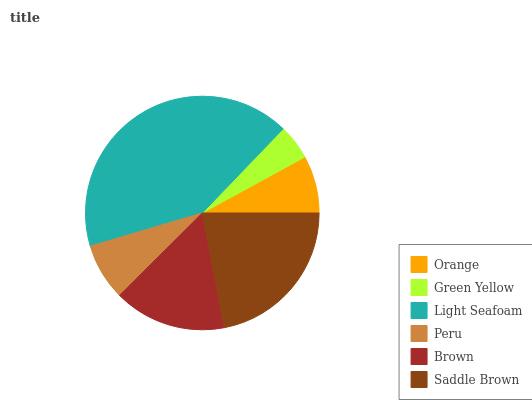Is Green Yellow the minimum?
Answer yes or no. Yes. Is Light Seafoam the maximum?
Answer yes or no. Yes. Is Light Seafoam the minimum?
Answer yes or no. No. Is Green Yellow the maximum?
Answer yes or no. No. Is Light Seafoam greater than Green Yellow?
Answer yes or no. Yes. Is Green Yellow less than Light Seafoam?
Answer yes or no. Yes. Is Green Yellow greater than Light Seafoam?
Answer yes or no. No. Is Light Seafoam less than Green Yellow?
Answer yes or no. No. Is Brown the high median?
Answer yes or no. Yes. Is Orange the low median?
Answer yes or no. Yes. Is Light Seafoam the high median?
Answer yes or no. No. Is Light Seafoam the low median?
Answer yes or no. No. 